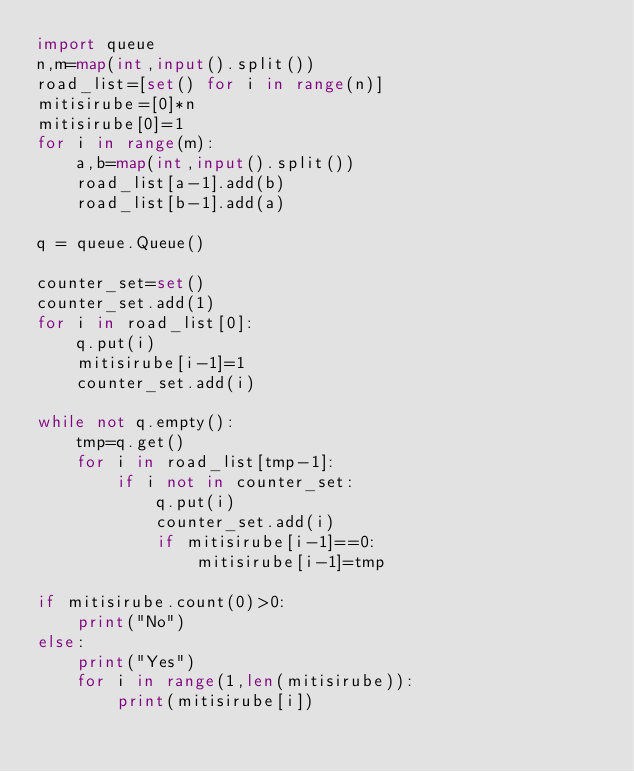<code> <loc_0><loc_0><loc_500><loc_500><_Python_>import queue
n,m=map(int,input().split())
road_list=[set() for i in range(n)]
mitisirube=[0]*n
mitisirube[0]=1
for i in range(m):
    a,b=map(int,input().split())
    road_list[a-1].add(b)
    road_list[b-1].add(a)

q = queue.Queue()

counter_set=set()
counter_set.add(1)
for i in road_list[0]:
    q.put(i)
    mitisirube[i-1]=1
    counter_set.add(i)

while not q.empty():
    tmp=q.get()
    for i in road_list[tmp-1]:
        if i not in counter_set:
            q.put(i)
            counter_set.add(i)
            if mitisirube[i-1]==0:
                mitisirube[i-1]=tmp

if mitisirube.count(0)>0:
    print("No")
else:
    print("Yes")
    for i in range(1,len(mitisirube)):
        print(mitisirube[i])</code> 